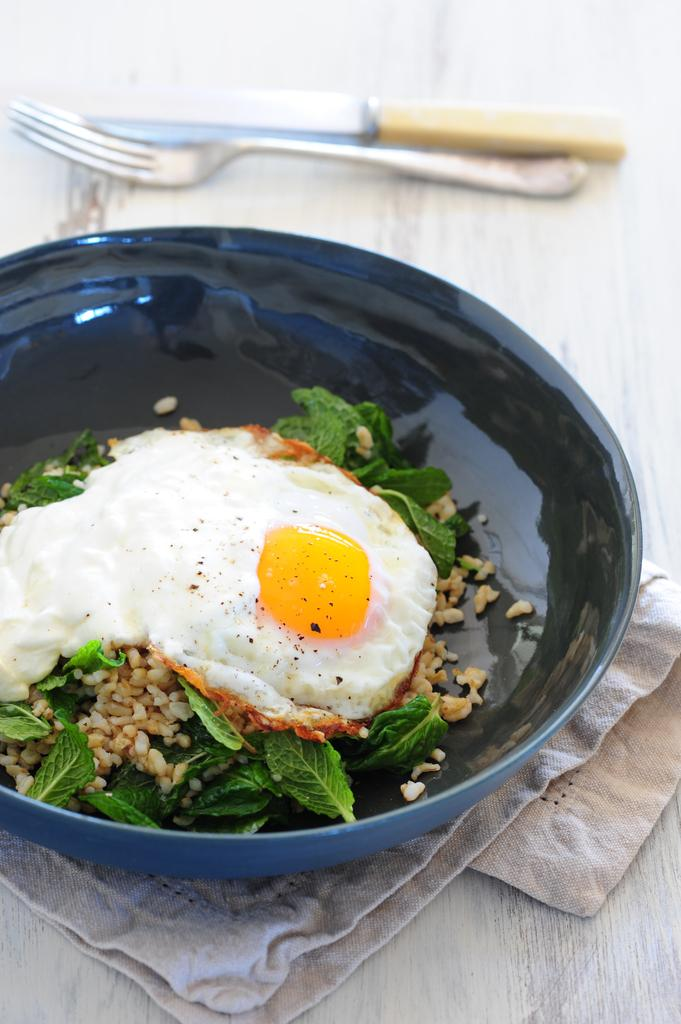What is in the bowl that is visible in the image? There is food in a bowl in the image. What colors are present on the bowl? The bowl has black and blue colors. What type of material is present in the image? There is a cloth in the image. What utensils are visible in the image? There is a spoon and a knife in the image. What is the color of the surface on which the objects are placed? The objects are on a white surface. What type of doll can be seen ringing the bells in the image? There is no doll or bells present in the image; it only features a bowl of food, a cloth, and utensils on a white surface. 